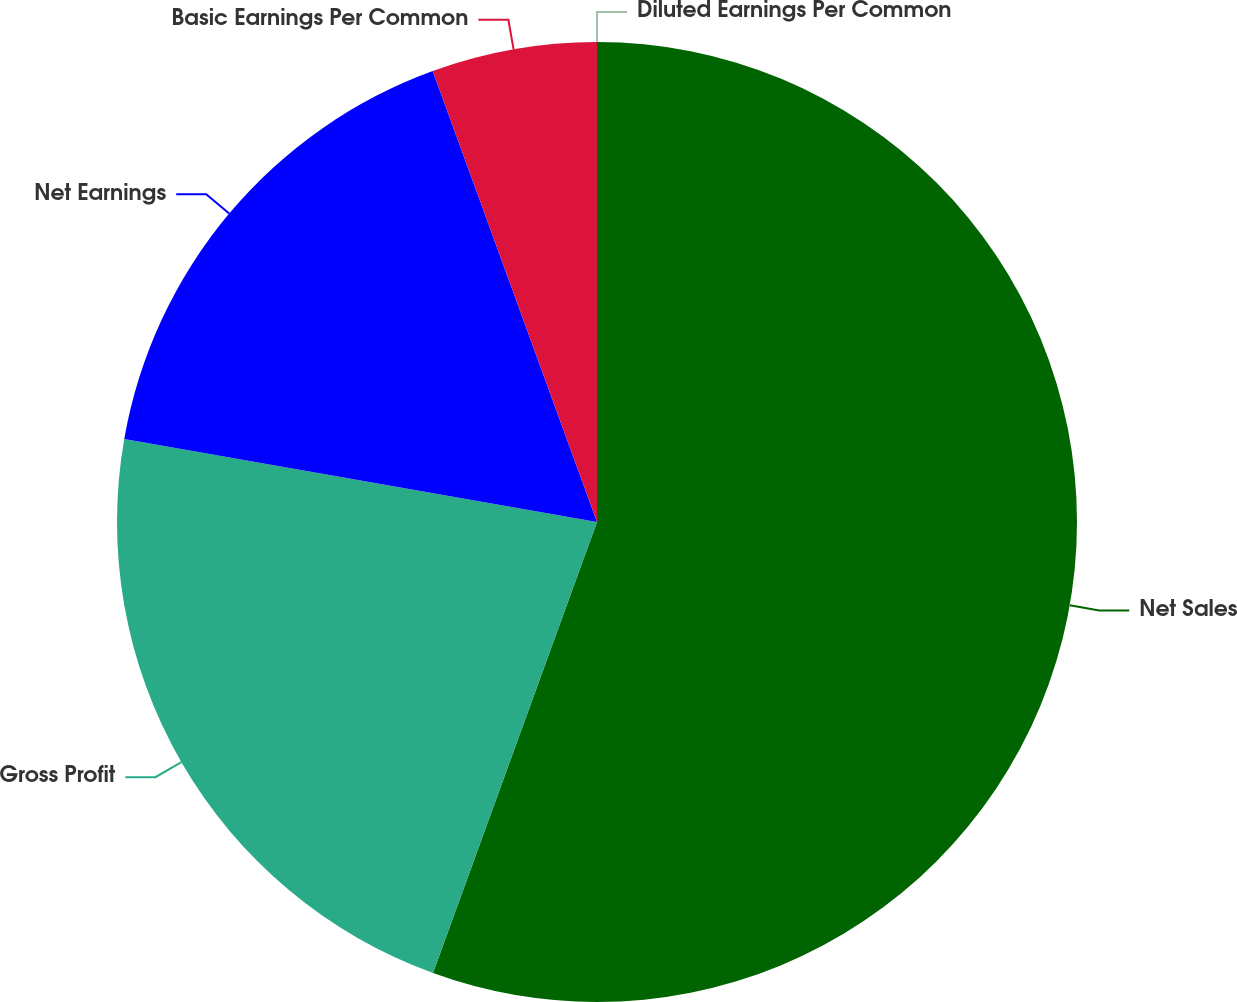<chart> <loc_0><loc_0><loc_500><loc_500><pie_chart><fcel>Net Sales<fcel>Gross Profit<fcel>Net Earnings<fcel>Basic Earnings Per Common<fcel>Diluted Earnings Per Common<nl><fcel>55.55%<fcel>22.22%<fcel>16.67%<fcel>5.56%<fcel>0.0%<nl></chart> 